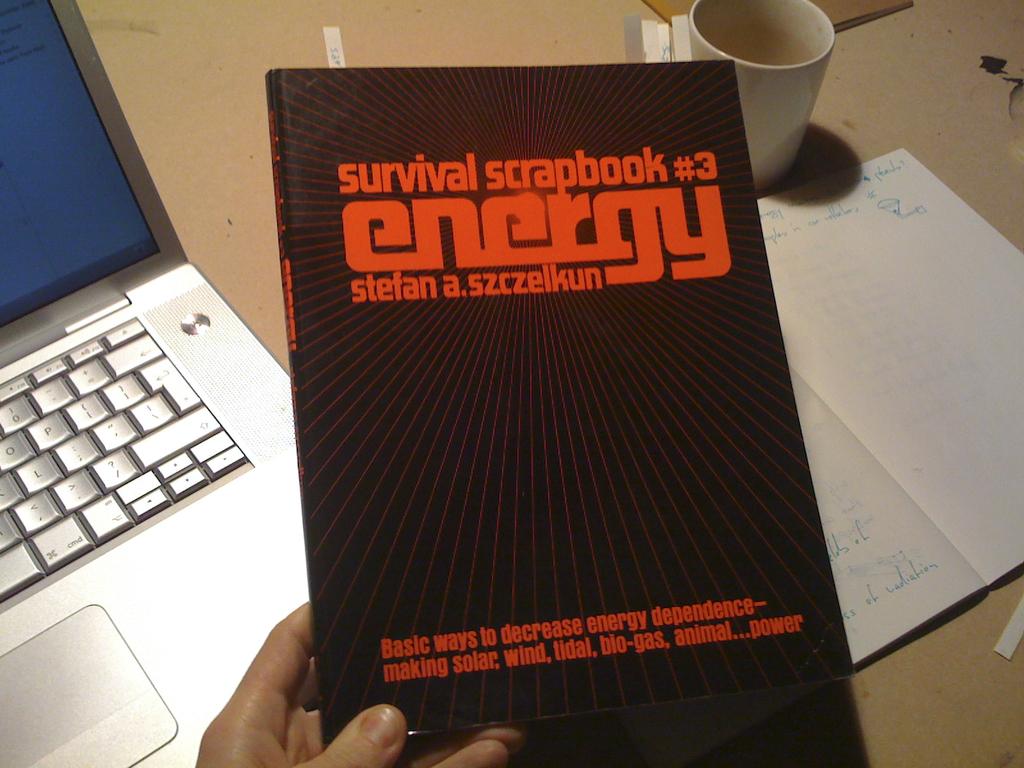Which volume is this?
Give a very brief answer. 3. What's the big word in the middle?
Your response must be concise. Energy. 